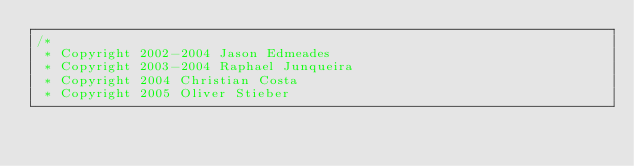<code> <loc_0><loc_0><loc_500><loc_500><_C_>/*
 * Copyright 2002-2004 Jason Edmeades
 * Copyright 2003-2004 Raphael Junqueira
 * Copyright 2004 Christian Costa
 * Copyright 2005 Oliver Stieber</code> 